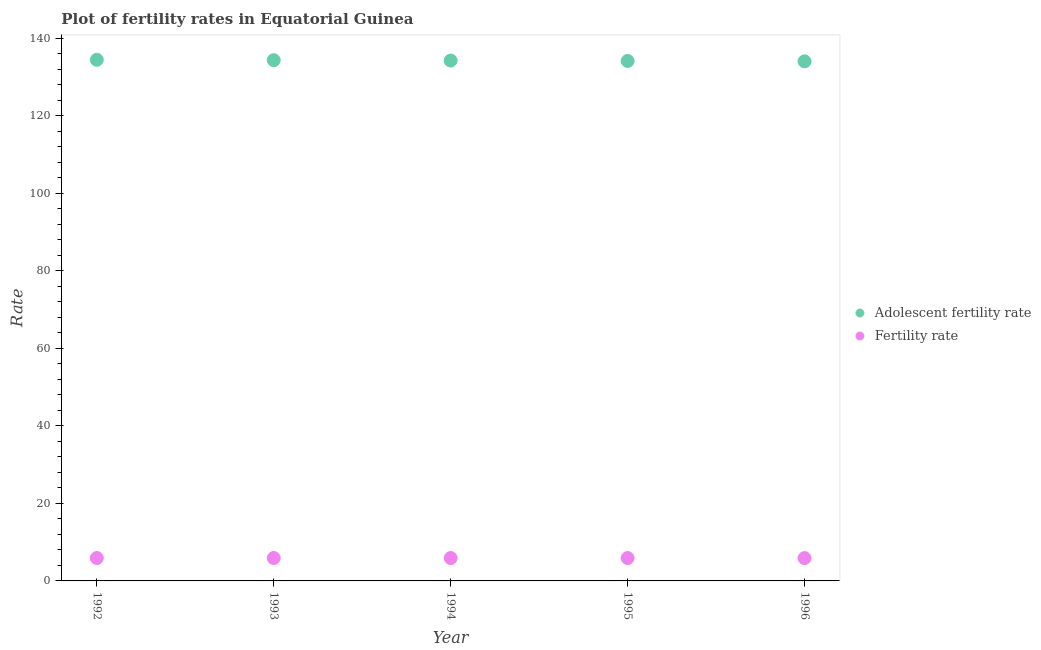How many different coloured dotlines are there?
Your response must be concise. 2. What is the adolescent fertility rate in 1996?
Make the answer very short. 134.01. Across all years, what is the maximum fertility rate?
Your answer should be very brief. 5.9. Across all years, what is the minimum fertility rate?
Keep it short and to the point. 5.89. In which year was the fertility rate maximum?
Your answer should be compact. 1992. In which year was the adolescent fertility rate minimum?
Provide a succinct answer. 1996. What is the total adolescent fertility rate in the graph?
Your response must be concise. 671.05. What is the difference between the adolescent fertility rate in 1992 and that in 1993?
Your answer should be compact. 0.1. What is the difference between the adolescent fertility rate in 1993 and the fertility rate in 1995?
Your answer should be very brief. 128.41. What is the average fertility rate per year?
Offer a terse response. 5.9. In the year 1995, what is the difference between the fertility rate and adolescent fertility rate?
Your response must be concise. -128.21. In how many years, is the fertility rate greater than 44?
Your answer should be very brief. 0. What is the ratio of the fertility rate in 1993 to that in 1996?
Make the answer very short. 1. What is the difference between the highest and the second highest adolescent fertility rate?
Offer a very short reply. 0.1. What is the difference between the highest and the lowest fertility rate?
Ensure brevity in your answer.  0.01. In how many years, is the fertility rate greater than the average fertility rate taken over all years?
Provide a succinct answer. 3. Does the fertility rate monotonically increase over the years?
Keep it short and to the point. No. Does the graph contain grids?
Make the answer very short. No. What is the title of the graph?
Make the answer very short. Plot of fertility rates in Equatorial Guinea. What is the label or title of the Y-axis?
Keep it short and to the point. Rate. What is the Rate in Adolescent fertility rate in 1992?
Offer a very short reply. 134.41. What is the Rate of Fertility rate in 1992?
Make the answer very short. 5.9. What is the Rate in Adolescent fertility rate in 1993?
Ensure brevity in your answer.  134.31. What is the Rate in Fertility rate in 1993?
Provide a short and direct response. 5.9. What is the Rate in Adolescent fertility rate in 1994?
Make the answer very short. 134.21. What is the Rate of Fertility rate in 1994?
Make the answer very short. 5.9. What is the Rate of Adolescent fertility rate in 1995?
Ensure brevity in your answer.  134.11. What is the Rate in Fertility rate in 1995?
Provide a short and direct response. 5.9. What is the Rate in Adolescent fertility rate in 1996?
Offer a very short reply. 134.01. What is the Rate of Fertility rate in 1996?
Your answer should be very brief. 5.89. Across all years, what is the maximum Rate in Adolescent fertility rate?
Provide a succinct answer. 134.41. Across all years, what is the maximum Rate of Fertility rate?
Make the answer very short. 5.9. Across all years, what is the minimum Rate in Adolescent fertility rate?
Offer a very short reply. 134.01. Across all years, what is the minimum Rate in Fertility rate?
Offer a terse response. 5.89. What is the total Rate in Adolescent fertility rate in the graph?
Offer a very short reply. 671.05. What is the total Rate in Fertility rate in the graph?
Your answer should be very brief. 29.49. What is the difference between the Rate in Adolescent fertility rate in 1992 and that in 1993?
Your response must be concise. 0.1. What is the difference between the Rate in Adolescent fertility rate in 1992 and that in 1994?
Offer a very short reply. 0.2. What is the difference between the Rate in Adolescent fertility rate in 1992 and that in 1995?
Make the answer very short. 0.3. What is the difference between the Rate in Fertility rate in 1992 and that in 1995?
Keep it short and to the point. 0.01. What is the difference between the Rate in Adolescent fertility rate in 1992 and that in 1996?
Keep it short and to the point. 0.4. What is the difference between the Rate in Fertility rate in 1992 and that in 1996?
Your answer should be very brief. 0.01. What is the difference between the Rate in Adolescent fertility rate in 1993 and that in 1994?
Your response must be concise. 0.1. What is the difference between the Rate in Fertility rate in 1993 and that in 1994?
Provide a short and direct response. 0. What is the difference between the Rate of Adolescent fertility rate in 1993 and that in 1995?
Keep it short and to the point. 0.2. What is the difference between the Rate in Fertility rate in 1993 and that in 1995?
Provide a succinct answer. 0.01. What is the difference between the Rate of Adolescent fertility rate in 1993 and that in 1996?
Keep it short and to the point. 0.3. What is the difference between the Rate in Fertility rate in 1993 and that in 1996?
Make the answer very short. 0.01. What is the difference between the Rate of Adolescent fertility rate in 1994 and that in 1995?
Give a very brief answer. 0.1. What is the difference between the Rate of Fertility rate in 1994 and that in 1995?
Keep it short and to the point. 0. What is the difference between the Rate of Adolescent fertility rate in 1994 and that in 1996?
Your response must be concise. 0.2. What is the difference between the Rate of Fertility rate in 1994 and that in 1996?
Offer a very short reply. 0.01. What is the difference between the Rate in Adolescent fertility rate in 1995 and that in 1996?
Make the answer very short. 0.1. What is the difference between the Rate of Fertility rate in 1995 and that in 1996?
Your response must be concise. 0.01. What is the difference between the Rate of Adolescent fertility rate in 1992 and the Rate of Fertility rate in 1993?
Keep it short and to the point. 128.51. What is the difference between the Rate of Adolescent fertility rate in 1992 and the Rate of Fertility rate in 1994?
Your answer should be compact. 128.51. What is the difference between the Rate of Adolescent fertility rate in 1992 and the Rate of Fertility rate in 1995?
Your answer should be very brief. 128.51. What is the difference between the Rate of Adolescent fertility rate in 1992 and the Rate of Fertility rate in 1996?
Ensure brevity in your answer.  128.52. What is the difference between the Rate of Adolescent fertility rate in 1993 and the Rate of Fertility rate in 1994?
Provide a succinct answer. 128.41. What is the difference between the Rate in Adolescent fertility rate in 1993 and the Rate in Fertility rate in 1995?
Give a very brief answer. 128.41. What is the difference between the Rate in Adolescent fertility rate in 1993 and the Rate in Fertility rate in 1996?
Your answer should be compact. 128.42. What is the difference between the Rate of Adolescent fertility rate in 1994 and the Rate of Fertility rate in 1995?
Keep it short and to the point. 128.31. What is the difference between the Rate of Adolescent fertility rate in 1994 and the Rate of Fertility rate in 1996?
Your response must be concise. 128.32. What is the difference between the Rate in Adolescent fertility rate in 1995 and the Rate in Fertility rate in 1996?
Make the answer very short. 128.22. What is the average Rate of Adolescent fertility rate per year?
Offer a terse response. 134.21. What is the average Rate in Fertility rate per year?
Keep it short and to the point. 5.9. In the year 1992, what is the difference between the Rate of Adolescent fertility rate and Rate of Fertility rate?
Your answer should be very brief. 128.51. In the year 1993, what is the difference between the Rate in Adolescent fertility rate and Rate in Fertility rate?
Keep it short and to the point. 128.41. In the year 1994, what is the difference between the Rate of Adolescent fertility rate and Rate of Fertility rate?
Your response must be concise. 128.31. In the year 1995, what is the difference between the Rate in Adolescent fertility rate and Rate in Fertility rate?
Provide a succinct answer. 128.21. In the year 1996, what is the difference between the Rate in Adolescent fertility rate and Rate in Fertility rate?
Make the answer very short. 128.12. What is the ratio of the Rate in Adolescent fertility rate in 1992 to that in 1995?
Your response must be concise. 1. What is the ratio of the Rate of Fertility rate in 1992 to that in 1995?
Offer a terse response. 1. What is the ratio of the Rate of Fertility rate in 1992 to that in 1996?
Provide a short and direct response. 1. What is the ratio of the Rate of Adolescent fertility rate in 1993 to that in 1994?
Your answer should be very brief. 1. What is the ratio of the Rate of Fertility rate in 1993 to that in 1994?
Offer a terse response. 1. What is the ratio of the Rate of Adolescent fertility rate in 1994 to that in 1996?
Offer a terse response. 1. What is the ratio of the Rate in Fertility rate in 1994 to that in 1996?
Offer a very short reply. 1. What is the difference between the highest and the second highest Rate of Adolescent fertility rate?
Your answer should be very brief. 0.1. What is the difference between the highest and the second highest Rate of Fertility rate?
Your answer should be very brief. 0. What is the difference between the highest and the lowest Rate of Adolescent fertility rate?
Keep it short and to the point. 0.4. What is the difference between the highest and the lowest Rate in Fertility rate?
Make the answer very short. 0.01. 